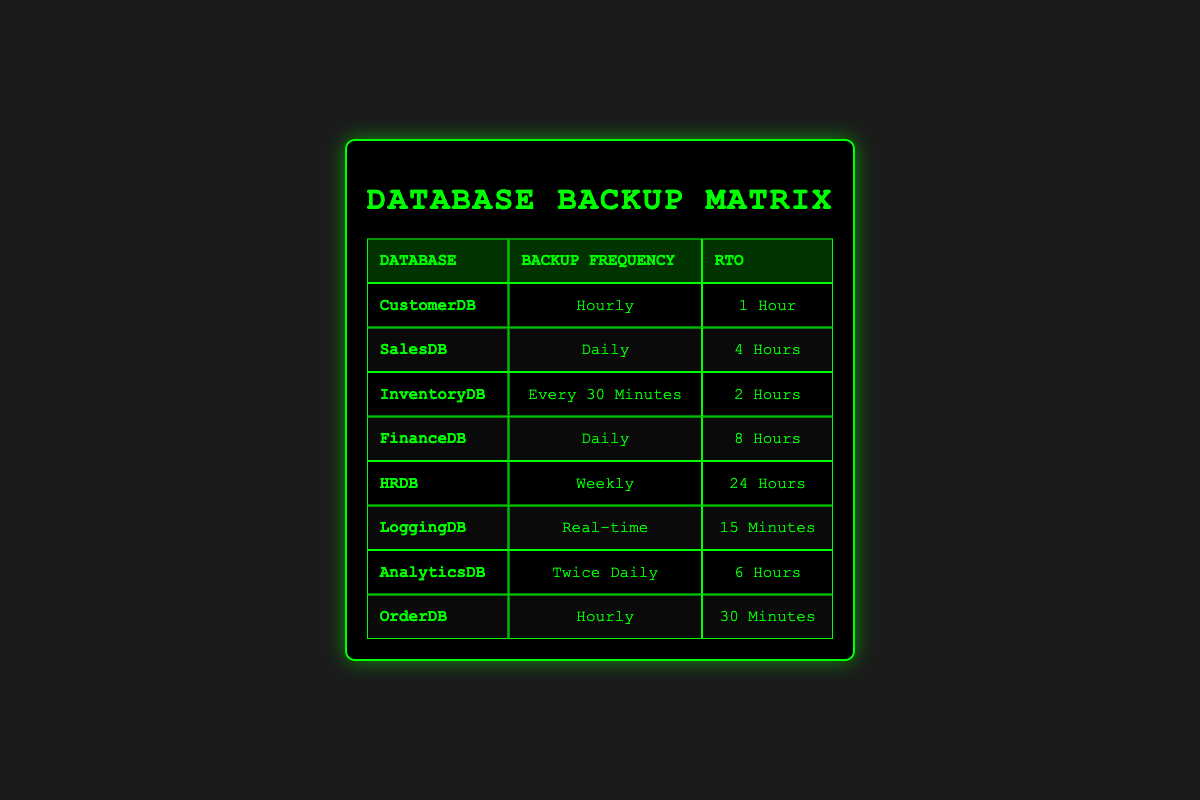What is the backup frequency for the LoggingDB? The table specifies that the backup frequency for LoggingDB is "Real-time". This is a direct retrieval of information from the relevant row in the table.
Answer: Real-time Which database has the longest Recovery Time Objective (RTO)? Upon reviewing the RTOs listed, the HRDB has the longest RTO at "24 Hours", indicating that it takes the most time to recover. This involves comparing all RTO values in the table.
Answer: HRDB Is there a database that has an RTO of less than 1 hour? By examining the RTOs in the table, the only database with an RTO of less than 1 hour is LoggingDB, which has an RTO of "15 Minutes". This is a straightforward yes/no type question.
Answer: Yes What is the average RTO for databases backed up daily? For the databases backed up daily, three entries are FinanceDB, SalesDB, and AnalyticsDB with RTOs of 8 hours, 4 hours, and 6 hours respectively. First, we sum these: 8 + 4 + 6 = 18 hours. Then we divide by the number of entries, which is 3. Thus, 18 hours / 3 = 6 hours as the average RTO.
Answer: 6 hours How many databases are backed up hourly, and what are their names? The table lists CustomerDB and OrderDB both with a backup frequency of "Hourly". Hence, there are two databases that fit this criterion. This involves counting the relevant entries and identifying their names.
Answer: 2; CustomerDB, OrderDB Are there any databases that have the same backup frequency and RTO? Checking the data, none of the databases have identical combinations of backup frequency and RTO. Each entry is unique. We cross-reference all rows in the table for duplication.
Answer: No What is the RTO difference between InventoryDB and SalesDB? The RTO for InventoryDB is "2 Hours" and for SalesDB is "4 Hours". To find the difference we subtract: 4 hours - 2 hours = 2 hours. This involves simple subtraction of the two values.
Answer: 2 hours Which database has a shorter RTO: AnalyticsDB or FinanceDB? AnalyticsDB has an RTO of "6 Hours", while FinanceDB has an RTO of "8 Hours". Comparing these two values, AnalyticsDB has the shorter RTO, which is a direct comparison of the two entries.
Answer: AnalyticsDB 